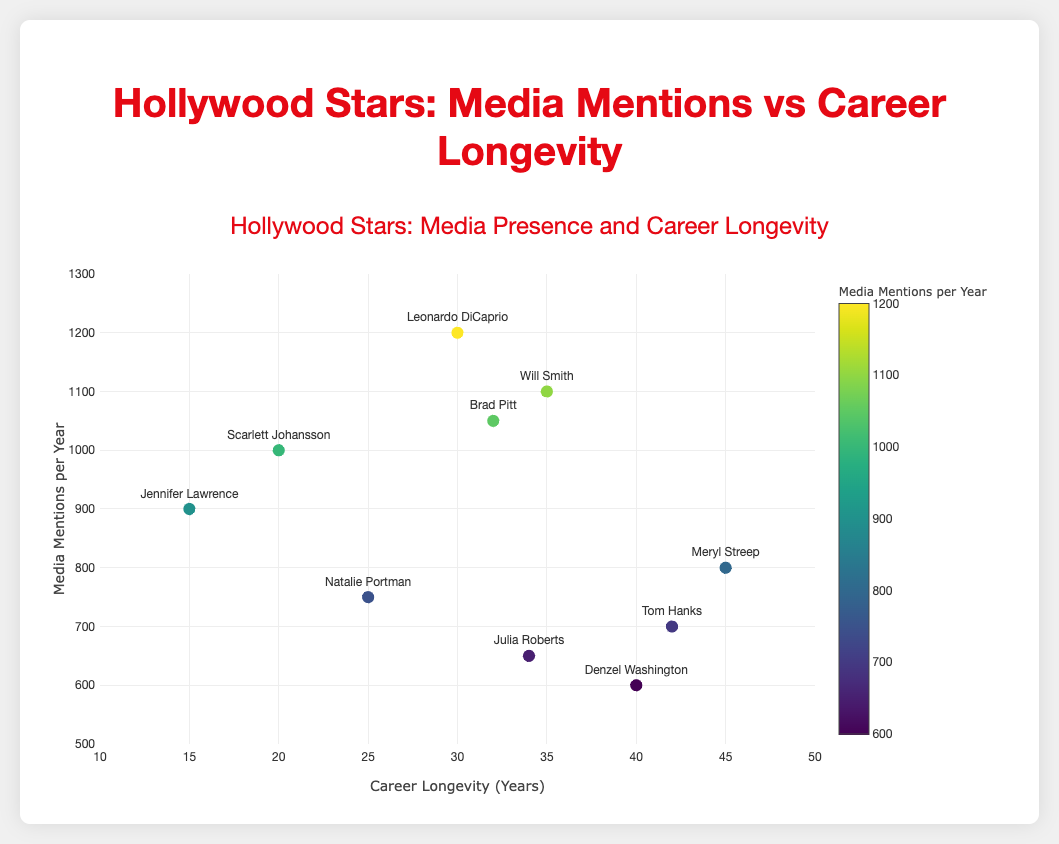How many data points are there in the scatter plot? Count the number of actors listed in the data to find the total number of data points.
Answer: 10 What is the title of the scatter plot? Look at the title text above the scatter plot.
Answer: Hollywood Stars: Media Presence and Career Longevity Which actor has the highest number of media mentions per year? Identify the actor whose data point is highest on the y-axis.
Answer: Leonardo DiCaprio Which actor has the longest career longevity? Identify the actor whose data point is farthest to the right on the x-axis.
Answer: Meryl Streep What is the range of career longevity years displayed on the x-axis? Look at the x-axis and note the values at the beginning and end.
Answer: 10 to 50 years How do the media mentions of Scarlett Johansson compare to those of Jennifer Lawrence? Compare the y-values (media mentions per year) of Scarlett Johansson and Jennifer Lawrence.
Answer: Scarlett Johansson has more media mentions per year (1000 vs 900) What is the difference in career longevity between Leonardo DiCaprio and Meryl Streep? Subtract Leonardo DiCaprio's career longevity from Meryl Streep's career longevity (45 - 30).
Answer: 15 years Are there more actors with career longevity over 30 years or under 30 years? Count the number of data points with career longevity greater than 30 years and those less than or equal to 30 years.
Answer: Over 30 years What is the average media mention per year for actors with career longevity greater than 30 years? Add media mentions per year of actors with longevity > 30 years and divide by the number of such actors. ((800 + 600 + 700 + 1100 + 650) / 5)
Answer: 770 Which actor has the closest career longevity to the median value of career longevity? Sort career longevity values, find the median (5th value in the sorted list), identify the actor with that value.
Answer: Will Smith 